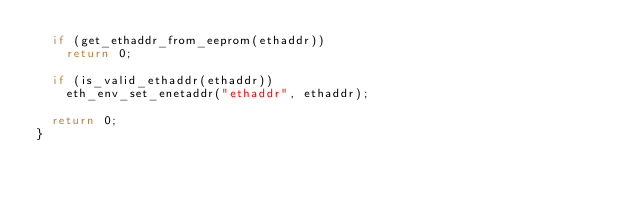<code> <loc_0><loc_0><loc_500><loc_500><_C_>	if (get_ethaddr_from_eeprom(ethaddr))
		return 0;

	if (is_valid_ethaddr(ethaddr))
		eth_env_set_enetaddr("ethaddr", ethaddr);

	return 0;
}
</code> 